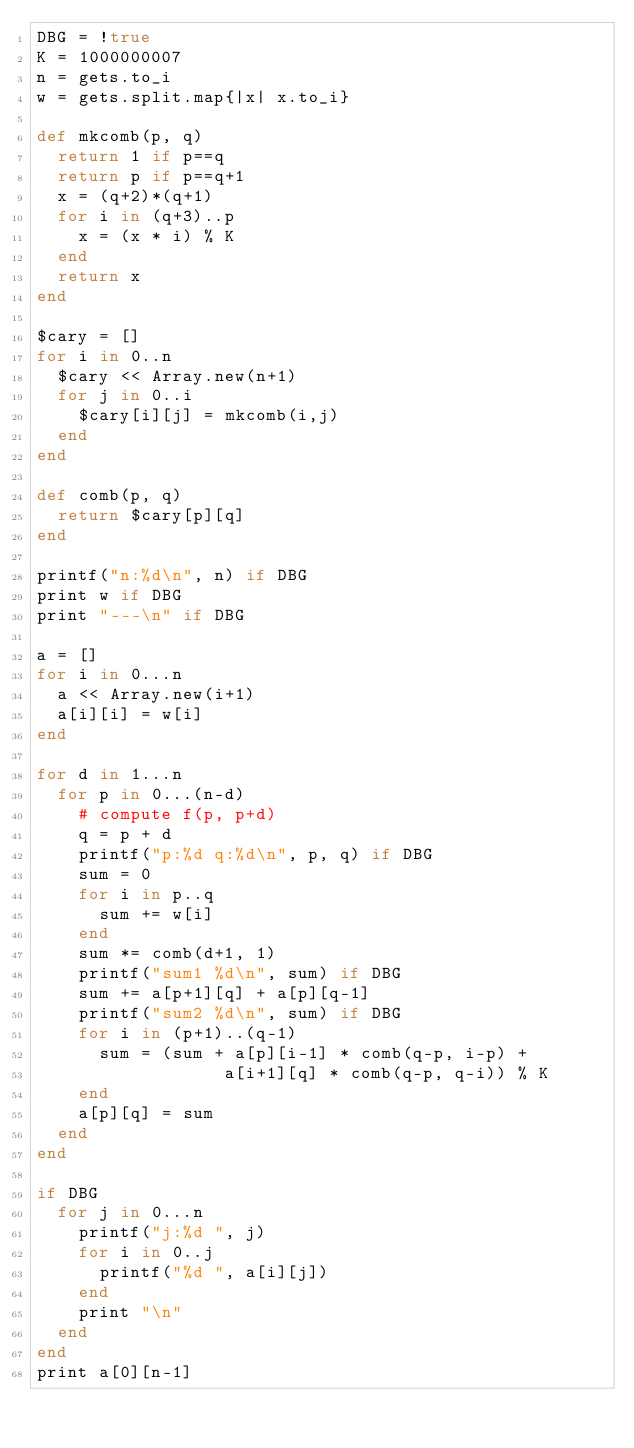Convert code to text. <code><loc_0><loc_0><loc_500><loc_500><_Ruby_>DBG = !true
K = 1000000007
n = gets.to_i
w = gets.split.map{|x| x.to_i}

def mkcomb(p, q)
  return 1 if p==q
  return p if p==q+1
  x = (q+2)*(q+1)
  for i in (q+3)..p
    x = (x * i) % K
  end
  return x
end

$cary = []
for i in 0..n
  $cary << Array.new(n+1)
  for j in 0..i
    $cary[i][j] = mkcomb(i,j)
  end
end

def comb(p, q)
  return $cary[p][q]
end

printf("n:%d\n", n) if DBG
print w if DBG
print "---\n" if DBG

a = []
for i in 0...n
  a << Array.new(i+1)
  a[i][i] = w[i]
end

for d in 1...n
  for p in 0...(n-d)
    # compute f(p, p+d)
    q = p + d
    printf("p:%d q:%d\n", p, q) if DBG
    sum = 0
    for i in p..q
      sum += w[i]
    end
    sum *= comb(d+1, 1)
    printf("sum1 %d\n", sum) if DBG
    sum += a[p+1][q] + a[p][q-1]
    printf("sum2 %d\n", sum) if DBG
    for i in (p+1)..(q-1)
      sum = (sum + a[p][i-1] * comb(q-p, i-p) +
                  a[i+1][q] * comb(q-p, q-i)) % K
    end
    a[p][q] = sum
  end
end

if DBG
  for j in 0...n
    printf("j:%d ", j)
    for i in 0..j
      printf("%d ", a[i][j])
    end
    print "\n"
  end
end
print a[0][n-1]
</code> 